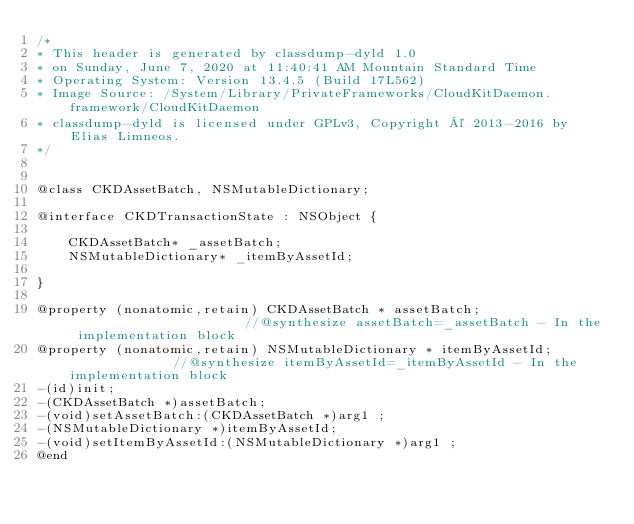<code> <loc_0><loc_0><loc_500><loc_500><_C_>/*
* This header is generated by classdump-dyld 1.0
* on Sunday, June 7, 2020 at 11:40:41 AM Mountain Standard Time
* Operating System: Version 13.4.5 (Build 17L562)
* Image Source: /System/Library/PrivateFrameworks/CloudKitDaemon.framework/CloudKitDaemon
* classdump-dyld is licensed under GPLv3, Copyright © 2013-2016 by Elias Limneos.
*/


@class CKDAssetBatch, NSMutableDictionary;

@interface CKDTransactionState : NSObject {

	CKDAssetBatch* _assetBatch;
	NSMutableDictionary* _itemByAssetId;

}

@property (nonatomic,retain) CKDAssetBatch * assetBatch;                       //@synthesize assetBatch=_assetBatch - In the implementation block
@property (nonatomic,retain) NSMutableDictionary * itemByAssetId;              //@synthesize itemByAssetId=_itemByAssetId - In the implementation block
-(id)init;
-(CKDAssetBatch *)assetBatch;
-(void)setAssetBatch:(CKDAssetBatch *)arg1 ;
-(NSMutableDictionary *)itemByAssetId;
-(void)setItemByAssetId:(NSMutableDictionary *)arg1 ;
@end

</code> 